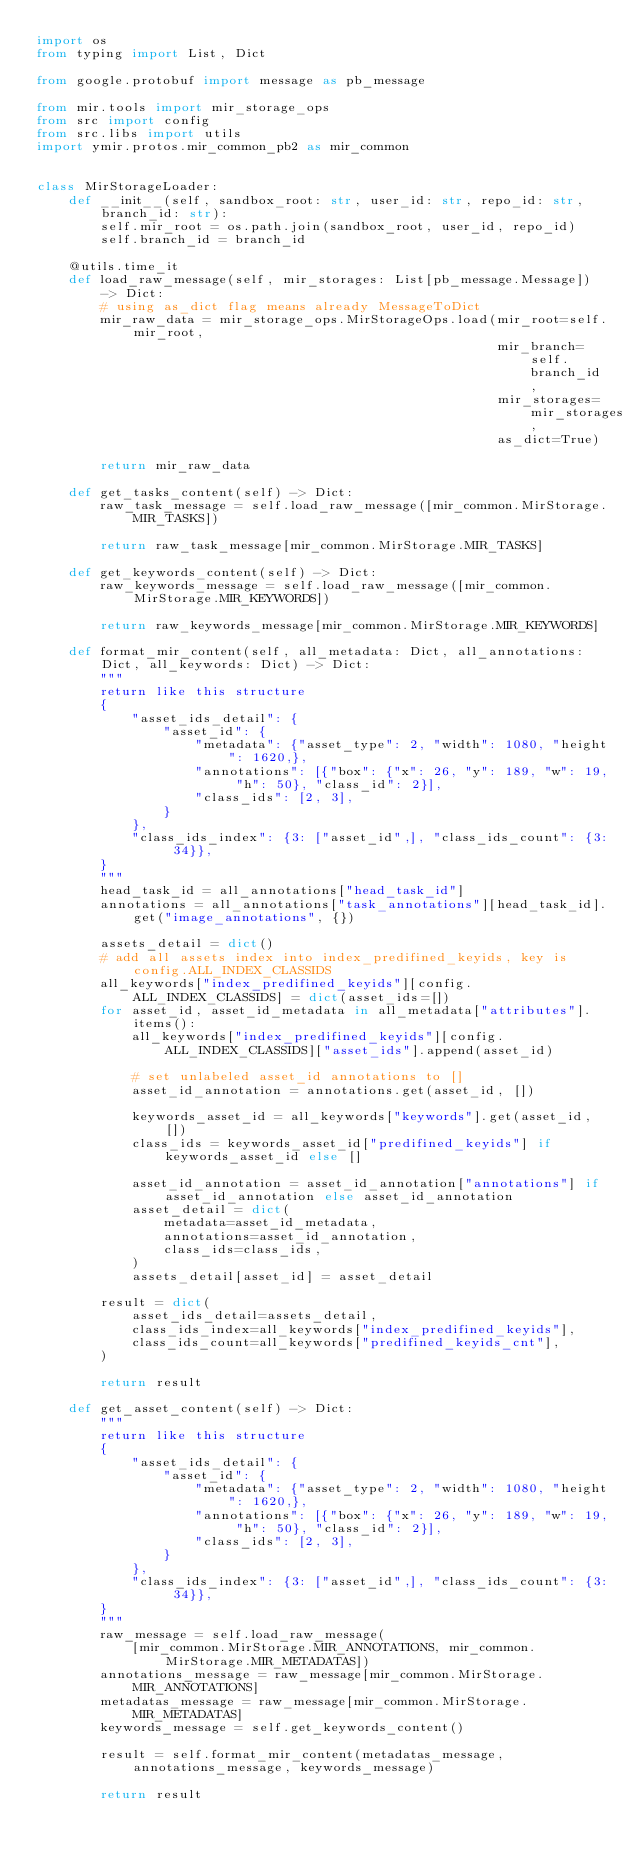<code> <loc_0><loc_0><loc_500><loc_500><_Python_>import os
from typing import List, Dict

from google.protobuf import message as pb_message

from mir.tools import mir_storage_ops
from src import config
from src.libs import utils
import ymir.protos.mir_common_pb2 as mir_common


class MirStorageLoader:
    def __init__(self, sandbox_root: str, user_id: str, repo_id: str, branch_id: str):
        self.mir_root = os.path.join(sandbox_root, user_id, repo_id)
        self.branch_id = branch_id

    @utils.time_it
    def load_raw_message(self, mir_storages: List[pb_message.Message]) -> Dict:
        # using as_dict flag means already MessageToDict
        mir_raw_data = mir_storage_ops.MirStorageOps.load(mir_root=self.mir_root,
                                                          mir_branch=self.branch_id,
                                                          mir_storages=mir_storages,
                                                          as_dict=True)

        return mir_raw_data

    def get_tasks_content(self) -> Dict:
        raw_task_message = self.load_raw_message([mir_common.MirStorage.MIR_TASKS])

        return raw_task_message[mir_common.MirStorage.MIR_TASKS]

    def get_keywords_content(self) -> Dict:
        raw_keywords_message = self.load_raw_message([mir_common.MirStorage.MIR_KEYWORDS])

        return raw_keywords_message[mir_common.MirStorage.MIR_KEYWORDS]

    def format_mir_content(self, all_metadata: Dict, all_annotations: Dict, all_keywords: Dict) -> Dict:
        """
        return like this structure
        {
            "asset_ids_detail": {
                "asset_id": {
                    "metadata": {"asset_type": 2, "width": 1080, "height": 1620,},
                    "annotations": [{"box": {"x": 26, "y": 189, "w": 19, "h": 50}, "class_id": 2}],
                    "class_ids": [2, 3],
                }
            },
            "class_ids_index": {3: ["asset_id",], "class_ids_count": {3: 34}},
        }
        """
        head_task_id = all_annotations["head_task_id"]
        annotations = all_annotations["task_annotations"][head_task_id].get("image_annotations", {})

        assets_detail = dict()
        # add all assets index into index_predifined_keyids, key is config.ALL_INDEX_CLASSIDS
        all_keywords["index_predifined_keyids"][config.ALL_INDEX_CLASSIDS] = dict(asset_ids=[])
        for asset_id, asset_id_metadata in all_metadata["attributes"].items():
            all_keywords["index_predifined_keyids"][config.ALL_INDEX_CLASSIDS]["asset_ids"].append(asset_id)

            # set unlabeled asset_id annotations to []
            asset_id_annotation = annotations.get(asset_id, [])

            keywords_asset_id = all_keywords["keywords"].get(asset_id, [])
            class_ids = keywords_asset_id["predifined_keyids"] if keywords_asset_id else []

            asset_id_annotation = asset_id_annotation["annotations"] if asset_id_annotation else asset_id_annotation
            asset_detail = dict(
                metadata=asset_id_metadata,
                annotations=asset_id_annotation,
                class_ids=class_ids,
            )
            assets_detail[asset_id] = asset_detail

        result = dict(
            asset_ids_detail=assets_detail,
            class_ids_index=all_keywords["index_predifined_keyids"],
            class_ids_count=all_keywords["predifined_keyids_cnt"],
        )

        return result

    def get_asset_content(self) -> Dict:
        """
        return like this structure
        {
            "asset_ids_detail": {
                "asset_id": {
                    "metadata": {"asset_type": 2, "width": 1080, "height": 1620,},
                    "annotations": [{"box": {"x": 26, "y": 189, "w": 19, "h": 50}, "class_id": 2}],
                    "class_ids": [2, 3],
                }
            },
            "class_ids_index": {3: ["asset_id",], "class_ids_count": {3: 34}},
        }
        """
        raw_message = self.load_raw_message(
            [mir_common.MirStorage.MIR_ANNOTATIONS, mir_common.MirStorage.MIR_METADATAS])
        annotations_message = raw_message[mir_common.MirStorage.MIR_ANNOTATIONS]
        metadatas_message = raw_message[mir_common.MirStorage.MIR_METADATAS]
        keywords_message = self.get_keywords_content()

        result = self.format_mir_content(metadatas_message, annotations_message, keywords_message)

        return result
</code> 